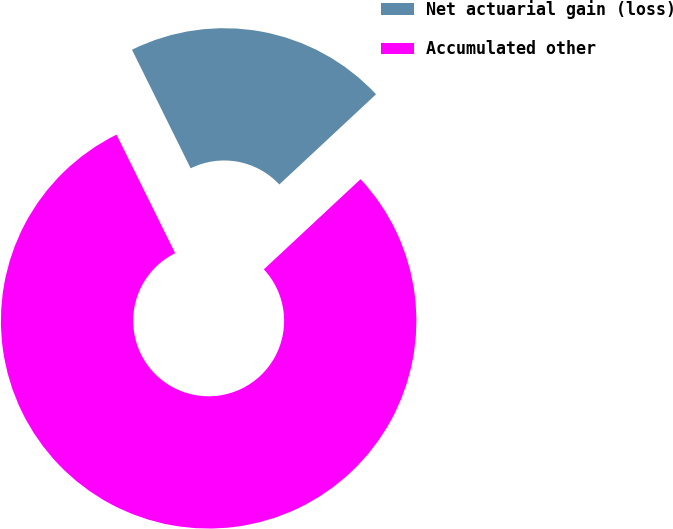Convert chart. <chart><loc_0><loc_0><loc_500><loc_500><pie_chart><fcel>Net actuarial gain (loss)<fcel>Accumulated other<nl><fcel>20.37%<fcel>79.63%<nl></chart> 